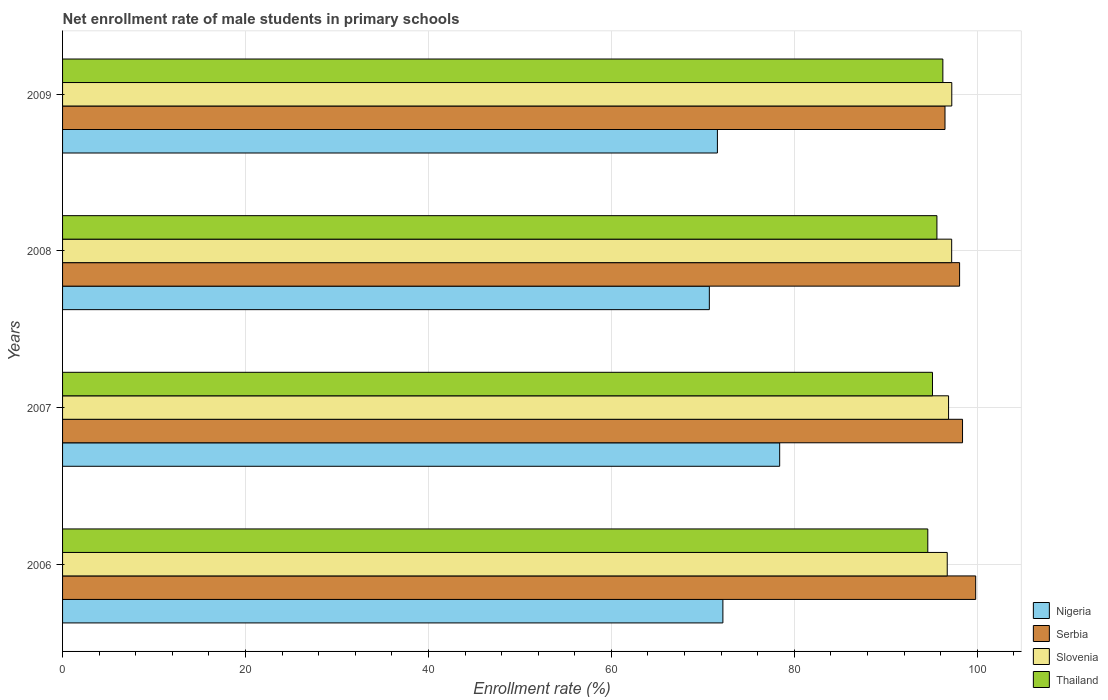How many groups of bars are there?
Offer a terse response. 4. How many bars are there on the 4th tick from the bottom?
Keep it short and to the point. 4. What is the net enrollment rate of male students in primary schools in Thailand in 2006?
Provide a succinct answer. 94.6. Across all years, what is the maximum net enrollment rate of male students in primary schools in Nigeria?
Your answer should be very brief. 78.4. Across all years, what is the minimum net enrollment rate of male students in primary schools in Nigeria?
Offer a terse response. 70.72. In which year was the net enrollment rate of male students in primary schools in Slovenia maximum?
Your response must be concise. 2009. In which year was the net enrollment rate of male students in primary schools in Nigeria minimum?
Your response must be concise. 2008. What is the total net enrollment rate of male students in primary schools in Slovenia in the graph?
Make the answer very short. 388.03. What is the difference between the net enrollment rate of male students in primary schools in Serbia in 2006 and that in 2009?
Offer a terse response. 3.36. What is the difference between the net enrollment rate of male students in primary schools in Nigeria in 2006 and the net enrollment rate of male students in primary schools in Slovenia in 2008?
Your answer should be compact. -25.01. What is the average net enrollment rate of male students in primary schools in Serbia per year?
Provide a succinct answer. 98.2. In the year 2008, what is the difference between the net enrollment rate of male students in primary schools in Slovenia and net enrollment rate of male students in primary schools in Nigeria?
Your answer should be very brief. 26.49. What is the ratio of the net enrollment rate of male students in primary schools in Nigeria in 2006 to that in 2009?
Provide a succinct answer. 1.01. Is the net enrollment rate of male students in primary schools in Nigeria in 2008 less than that in 2009?
Provide a short and direct response. Yes. What is the difference between the highest and the second highest net enrollment rate of male students in primary schools in Thailand?
Offer a terse response. 0.65. What is the difference between the highest and the lowest net enrollment rate of male students in primary schools in Slovenia?
Provide a succinct answer. 0.5. In how many years, is the net enrollment rate of male students in primary schools in Slovenia greater than the average net enrollment rate of male students in primary schools in Slovenia taken over all years?
Your answer should be compact. 2. Is the sum of the net enrollment rate of male students in primary schools in Serbia in 2007 and 2008 greater than the maximum net enrollment rate of male students in primary schools in Nigeria across all years?
Provide a succinct answer. Yes. Is it the case that in every year, the sum of the net enrollment rate of male students in primary schools in Serbia and net enrollment rate of male students in primary schools in Nigeria is greater than the sum of net enrollment rate of male students in primary schools in Slovenia and net enrollment rate of male students in primary schools in Thailand?
Your response must be concise. Yes. What does the 4th bar from the top in 2006 represents?
Ensure brevity in your answer.  Nigeria. What does the 2nd bar from the bottom in 2009 represents?
Your answer should be very brief. Serbia. Are all the bars in the graph horizontal?
Offer a terse response. Yes. How many years are there in the graph?
Your answer should be very brief. 4. Are the values on the major ticks of X-axis written in scientific E-notation?
Keep it short and to the point. No. Does the graph contain any zero values?
Offer a terse response. No. Does the graph contain grids?
Ensure brevity in your answer.  Yes. How many legend labels are there?
Your answer should be very brief. 4. How are the legend labels stacked?
Offer a terse response. Vertical. What is the title of the graph?
Ensure brevity in your answer.  Net enrollment rate of male students in primary schools. What is the label or title of the X-axis?
Offer a very short reply. Enrollment rate (%). What is the label or title of the Y-axis?
Offer a very short reply. Years. What is the Enrollment rate (%) of Nigeria in 2006?
Offer a terse response. 72.2. What is the Enrollment rate (%) of Serbia in 2006?
Your response must be concise. 99.84. What is the Enrollment rate (%) of Slovenia in 2006?
Provide a succinct answer. 96.72. What is the Enrollment rate (%) of Thailand in 2006?
Provide a short and direct response. 94.6. What is the Enrollment rate (%) in Nigeria in 2007?
Offer a very short reply. 78.4. What is the Enrollment rate (%) of Serbia in 2007?
Provide a short and direct response. 98.4. What is the Enrollment rate (%) in Slovenia in 2007?
Your answer should be very brief. 96.87. What is the Enrollment rate (%) of Thailand in 2007?
Ensure brevity in your answer.  95.11. What is the Enrollment rate (%) in Nigeria in 2008?
Keep it short and to the point. 70.72. What is the Enrollment rate (%) of Serbia in 2008?
Provide a succinct answer. 98.08. What is the Enrollment rate (%) in Slovenia in 2008?
Make the answer very short. 97.21. What is the Enrollment rate (%) of Thailand in 2008?
Your response must be concise. 95.6. What is the Enrollment rate (%) in Nigeria in 2009?
Provide a short and direct response. 71.6. What is the Enrollment rate (%) of Serbia in 2009?
Offer a very short reply. 96.48. What is the Enrollment rate (%) of Slovenia in 2009?
Make the answer very short. 97.22. What is the Enrollment rate (%) of Thailand in 2009?
Keep it short and to the point. 96.25. Across all years, what is the maximum Enrollment rate (%) of Nigeria?
Ensure brevity in your answer.  78.4. Across all years, what is the maximum Enrollment rate (%) in Serbia?
Ensure brevity in your answer.  99.84. Across all years, what is the maximum Enrollment rate (%) in Slovenia?
Your answer should be compact. 97.22. Across all years, what is the maximum Enrollment rate (%) of Thailand?
Provide a succinct answer. 96.25. Across all years, what is the minimum Enrollment rate (%) of Nigeria?
Offer a very short reply. 70.72. Across all years, what is the minimum Enrollment rate (%) of Serbia?
Ensure brevity in your answer.  96.48. Across all years, what is the minimum Enrollment rate (%) of Slovenia?
Your answer should be very brief. 96.72. Across all years, what is the minimum Enrollment rate (%) in Thailand?
Your answer should be compact. 94.6. What is the total Enrollment rate (%) in Nigeria in the graph?
Make the answer very short. 292.91. What is the total Enrollment rate (%) in Serbia in the graph?
Offer a very short reply. 392.79. What is the total Enrollment rate (%) of Slovenia in the graph?
Your answer should be compact. 388.03. What is the total Enrollment rate (%) in Thailand in the graph?
Make the answer very short. 381.56. What is the difference between the Enrollment rate (%) of Nigeria in 2006 and that in 2007?
Provide a short and direct response. -6.21. What is the difference between the Enrollment rate (%) in Serbia in 2006 and that in 2007?
Ensure brevity in your answer.  1.44. What is the difference between the Enrollment rate (%) in Slovenia in 2006 and that in 2007?
Provide a short and direct response. -0.15. What is the difference between the Enrollment rate (%) of Thailand in 2006 and that in 2007?
Keep it short and to the point. -0.51. What is the difference between the Enrollment rate (%) in Nigeria in 2006 and that in 2008?
Keep it short and to the point. 1.48. What is the difference between the Enrollment rate (%) of Serbia in 2006 and that in 2008?
Provide a short and direct response. 1.76. What is the difference between the Enrollment rate (%) of Slovenia in 2006 and that in 2008?
Your response must be concise. -0.49. What is the difference between the Enrollment rate (%) in Thailand in 2006 and that in 2008?
Provide a succinct answer. -1. What is the difference between the Enrollment rate (%) of Nigeria in 2006 and that in 2009?
Give a very brief answer. 0.6. What is the difference between the Enrollment rate (%) in Serbia in 2006 and that in 2009?
Offer a terse response. 3.36. What is the difference between the Enrollment rate (%) of Slovenia in 2006 and that in 2009?
Keep it short and to the point. -0.5. What is the difference between the Enrollment rate (%) in Thailand in 2006 and that in 2009?
Provide a short and direct response. -1.65. What is the difference between the Enrollment rate (%) in Nigeria in 2007 and that in 2008?
Offer a terse response. 7.69. What is the difference between the Enrollment rate (%) in Serbia in 2007 and that in 2008?
Your answer should be very brief. 0.32. What is the difference between the Enrollment rate (%) in Slovenia in 2007 and that in 2008?
Your response must be concise. -0.34. What is the difference between the Enrollment rate (%) in Thailand in 2007 and that in 2008?
Your answer should be very brief. -0.49. What is the difference between the Enrollment rate (%) of Nigeria in 2007 and that in 2009?
Ensure brevity in your answer.  6.81. What is the difference between the Enrollment rate (%) in Serbia in 2007 and that in 2009?
Ensure brevity in your answer.  1.92. What is the difference between the Enrollment rate (%) in Slovenia in 2007 and that in 2009?
Provide a short and direct response. -0.35. What is the difference between the Enrollment rate (%) of Thailand in 2007 and that in 2009?
Ensure brevity in your answer.  -1.13. What is the difference between the Enrollment rate (%) of Nigeria in 2008 and that in 2009?
Provide a short and direct response. -0.88. What is the difference between the Enrollment rate (%) of Serbia in 2008 and that in 2009?
Provide a short and direct response. 1.6. What is the difference between the Enrollment rate (%) in Slovenia in 2008 and that in 2009?
Your answer should be very brief. -0.01. What is the difference between the Enrollment rate (%) in Thailand in 2008 and that in 2009?
Your answer should be compact. -0.65. What is the difference between the Enrollment rate (%) in Nigeria in 2006 and the Enrollment rate (%) in Serbia in 2007?
Offer a terse response. -26.2. What is the difference between the Enrollment rate (%) in Nigeria in 2006 and the Enrollment rate (%) in Slovenia in 2007?
Provide a succinct answer. -24.67. What is the difference between the Enrollment rate (%) in Nigeria in 2006 and the Enrollment rate (%) in Thailand in 2007?
Give a very brief answer. -22.92. What is the difference between the Enrollment rate (%) in Serbia in 2006 and the Enrollment rate (%) in Slovenia in 2007?
Keep it short and to the point. 2.97. What is the difference between the Enrollment rate (%) in Serbia in 2006 and the Enrollment rate (%) in Thailand in 2007?
Ensure brevity in your answer.  4.72. What is the difference between the Enrollment rate (%) in Slovenia in 2006 and the Enrollment rate (%) in Thailand in 2007?
Offer a very short reply. 1.61. What is the difference between the Enrollment rate (%) of Nigeria in 2006 and the Enrollment rate (%) of Serbia in 2008?
Your response must be concise. -25.88. What is the difference between the Enrollment rate (%) of Nigeria in 2006 and the Enrollment rate (%) of Slovenia in 2008?
Provide a succinct answer. -25.01. What is the difference between the Enrollment rate (%) of Nigeria in 2006 and the Enrollment rate (%) of Thailand in 2008?
Offer a very short reply. -23.4. What is the difference between the Enrollment rate (%) of Serbia in 2006 and the Enrollment rate (%) of Slovenia in 2008?
Give a very brief answer. 2.63. What is the difference between the Enrollment rate (%) in Serbia in 2006 and the Enrollment rate (%) in Thailand in 2008?
Keep it short and to the point. 4.24. What is the difference between the Enrollment rate (%) of Slovenia in 2006 and the Enrollment rate (%) of Thailand in 2008?
Ensure brevity in your answer.  1.13. What is the difference between the Enrollment rate (%) in Nigeria in 2006 and the Enrollment rate (%) in Serbia in 2009?
Provide a short and direct response. -24.29. What is the difference between the Enrollment rate (%) in Nigeria in 2006 and the Enrollment rate (%) in Slovenia in 2009?
Offer a terse response. -25.03. What is the difference between the Enrollment rate (%) in Nigeria in 2006 and the Enrollment rate (%) in Thailand in 2009?
Ensure brevity in your answer.  -24.05. What is the difference between the Enrollment rate (%) of Serbia in 2006 and the Enrollment rate (%) of Slovenia in 2009?
Give a very brief answer. 2.61. What is the difference between the Enrollment rate (%) of Serbia in 2006 and the Enrollment rate (%) of Thailand in 2009?
Make the answer very short. 3.59. What is the difference between the Enrollment rate (%) of Slovenia in 2006 and the Enrollment rate (%) of Thailand in 2009?
Give a very brief answer. 0.48. What is the difference between the Enrollment rate (%) of Nigeria in 2007 and the Enrollment rate (%) of Serbia in 2008?
Give a very brief answer. -19.67. What is the difference between the Enrollment rate (%) of Nigeria in 2007 and the Enrollment rate (%) of Slovenia in 2008?
Offer a terse response. -18.81. What is the difference between the Enrollment rate (%) of Nigeria in 2007 and the Enrollment rate (%) of Thailand in 2008?
Give a very brief answer. -17.19. What is the difference between the Enrollment rate (%) in Serbia in 2007 and the Enrollment rate (%) in Slovenia in 2008?
Keep it short and to the point. 1.19. What is the difference between the Enrollment rate (%) of Serbia in 2007 and the Enrollment rate (%) of Thailand in 2008?
Offer a very short reply. 2.8. What is the difference between the Enrollment rate (%) in Slovenia in 2007 and the Enrollment rate (%) in Thailand in 2008?
Provide a succinct answer. 1.27. What is the difference between the Enrollment rate (%) in Nigeria in 2007 and the Enrollment rate (%) in Serbia in 2009?
Give a very brief answer. -18.08. What is the difference between the Enrollment rate (%) in Nigeria in 2007 and the Enrollment rate (%) in Slovenia in 2009?
Ensure brevity in your answer.  -18.82. What is the difference between the Enrollment rate (%) in Nigeria in 2007 and the Enrollment rate (%) in Thailand in 2009?
Your response must be concise. -17.84. What is the difference between the Enrollment rate (%) of Serbia in 2007 and the Enrollment rate (%) of Slovenia in 2009?
Offer a very short reply. 1.17. What is the difference between the Enrollment rate (%) in Serbia in 2007 and the Enrollment rate (%) in Thailand in 2009?
Make the answer very short. 2.15. What is the difference between the Enrollment rate (%) in Slovenia in 2007 and the Enrollment rate (%) in Thailand in 2009?
Provide a succinct answer. 0.62. What is the difference between the Enrollment rate (%) of Nigeria in 2008 and the Enrollment rate (%) of Serbia in 2009?
Your answer should be very brief. -25.77. What is the difference between the Enrollment rate (%) in Nigeria in 2008 and the Enrollment rate (%) in Slovenia in 2009?
Make the answer very short. -26.51. What is the difference between the Enrollment rate (%) of Nigeria in 2008 and the Enrollment rate (%) of Thailand in 2009?
Offer a very short reply. -25.53. What is the difference between the Enrollment rate (%) of Serbia in 2008 and the Enrollment rate (%) of Slovenia in 2009?
Provide a succinct answer. 0.85. What is the difference between the Enrollment rate (%) of Serbia in 2008 and the Enrollment rate (%) of Thailand in 2009?
Provide a short and direct response. 1.83. What is the difference between the Enrollment rate (%) in Slovenia in 2008 and the Enrollment rate (%) in Thailand in 2009?
Your answer should be compact. 0.96. What is the average Enrollment rate (%) in Nigeria per year?
Your answer should be compact. 73.23. What is the average Enrollment rate (%) of Serbia per year?
Your answer should be very brief. 98.2. What is the average Enrollment rate (%) of Slovenia per year?
Provide a short and direct response. 97.01. What is the average Enrollment rate (%) in Thailand per year?
Keep it short and to the point. 95.39. In the year 2006, what is the difference between the Enrollment rate (%) in Nigeria and Enrollment rate (%) in Serbia?
Provide a short and direct response. -27.64. In the year 2006, what is the difference between the Enrollment rate (%) in Nigeria and Enrollment rate (%) in Slovenia?
Offer a very short reply. -24.53. In the year 2006, what is the difference between the Enrollment rate (%) of Nigeria and Enrollment rate (%) of Thailand?
Keep it short and to the point. -22.4. In the year 2006, what is the difference between the Enrollment rate (%) of Serbia and Enrollment rate (%) of Slovenia?
Your answer should be compact. 3.11. In the year 2006, what is the difference between the Enrollment rate (%) of Serbia and Enrollment rate (%) of Thailand?
Ensure brevity in your answer.  5.24. In the year 2006, what is the difference between the Enrollment rate (%) in Slovenia and Enrollment rate (%) in Thailand?
Ensure brevity in your answer.  2.12. In the year 2007, what is the difference between the Enrollment rate (%) in Nigeria and Enrollment rate (%) in Serbia?
Offer a terse response. -19.99. In the year 2007, what is the difference between the Enrollment rate (%) of Nigeria and Enrollment rate (%) of Slovenia?
Ensure brevity in your answer.  -18.47. In the year 2007, what is the difference between the Enrollment rate (%) of Nigeria and Enrollment rate (%) of Thailand?
Provide a succinct answer. -16.71. In the year 2007, what is the difference between the Enrollment rate (%) in Serbia and Enrollment rate (%) in Slovenia?
Give a very brief answer. 1.53. In the year 2007, what is the difference between the Enrollment rate (%) of Serbia and Enrollment rate (%) of Thailand?
Give a very brief answer. 3.29. In the year 2007, what is the difference between the Enrollment rate (%) of Slovenia and Enrollment rate (%) of Thailand?
Your response must be concise. 1.76. In the year 2008, what is the difference between the Enrollment rate (%) in Nigeria and Enrollment rate (%) in Serbia?
Your answer should be very brief. -27.36. In the year 2008, what is the difference between the Enrollment rate (%) in Nigeria and Enrollment rate (%) in Slovenia?
Provide a succinct answer. -26.5. In the year 2008, what is the difference between the Enrollment rate (%) in Nigeria and Enrollment rate (%) in Thailand?
Provide a short and direct response. -24.88. In the year 2008, what is the difference between the Enrollment rate (%) in Serbia and Enrollment rate (%) in Slovenia?
Your response must be concise. 0.87. In the year 2008, what is the difference between the Enrollment rate (%) in Serbia and Enrollment rate (%) in Thailand?
Your answer should be compact. 2.48. In the year 2008, what is the difference between the Enrollment rate (%) of Slovenia and Enrollment rate (%) of Thailand?
Your answer should be very brief. 1.61. In the year 2009, what is the difference between the Enrollment rate (%) of Nigeria and Enrollment rate (%) of Serbia?
Your answer should be compact. -24.88. In the year 2009, what is the difference between the Enrollment rate (%) of Nigeria and Enrollment rate (%) of Slovenia?
Provide a short and direct response. -25.63. In the year 2009, what is the difference between the Enrollment rate (%) of Nigeria and Enrollment rate (%) of Thailand?
Offer a terse response. -24.65. In the year 2009, what is the difference between the Enrollment rate (%) in Serbia and Enrollment rate (%) in Slovenia?
Give a very brief answer. -0.74. In the year 2009, what is the difference between the Enrollment rate (%) of Serbia and Enrollment rate (%) of Thailand?
Your answer should be very brief. 0.23. In the year 2009, what is the difference between the Enrollment rate (%) in Slovenia and Enrollment rate (%) in Thailand?
Provide a short and direct response. 0.98. What is the ratio of the Enrollment rate (%) in Nigeria in 2006 to that in 2007?
Ensure brevity in your answer.  0.92. What is the ratio of the Enrollment rate (%) of Serbia in 2006 to that in 2007?
Offer a very short reply. 1.01. What is the ratio of the Enrollment rate (%) of Thailand in 2006 to that in 2007?
Provide a short and direct response. 0.99. What is the ratio of the Enrollment rate (%) in Nigeria in 2006 to that in 2008?
Provide a short and direct response. 1.02. What is the ratio of the Enrollment rate (%) in Serbia in 2006 to that in 2008?
Make the answer very short. 1.02. What is the ratio of the Enrollment rate (%) of Nigeria in 2006 to that in 2009?
Offer a terse response. 1.01. What is the ratio of the Enrollment rate (%) in Serbia in 2006 to that in 2009?
Offer a very short reply. 1.03. What is the ratio of the Enrollment rate (%) of Slovenia in 2006 to that in 2009?
Your answer should be very brief. 0.99. What is the ratio of the Enrollment rate (%) of Thailand in 2006 to that in 2009?
Your answer should be very brief. 0.98. What is the ratio of the Enrollment rate (%) of Nigeria in 2007 to that in 2008?
Make the answer very short. 1.11. What is the ratio of the Enrollment rate (%) of Serbia in 2007 to that in 2008?
Make the answer very short. 1. What is the ratio of the Enrollment rate (%) of Slovenia in 2007 to that in 2008?
Provide a short and direct response. 1. What is the ratio of the Enrollment rate (%) in Nigeria in 2007 to that in 2009?
Offer a terse response. 1.1. What is the ratio of the Enrollment rate (%) of Serbia in 2007 to that in 2009?
Provide a short and direct response. 1.02. What is the ratio of the Enrollment rate (%) in Slovenia in 2007 to that in 2009?
Make the answer very short. 1. What is the ratio of the Enrollment rate (%) of Thailand in 2007 to that in 2009?
Make the answer very short. 0.99. What is the ratio of the Enrollment rate (%) of Nigeria in 2008 to that in 2009?
Ensure brevity in your answer.  0.99. What is the ratio of the Enrollment rate (%) in Serbia in 2008 to that in 2009?
Provide a succinct answer. 1.02. What is the difference between the highest and the second highest Enrollment rate (%) of Nigeria?
Give a very brief answer. 6.21. What is the difference between the highest and the second highest Enrollment rate (%) of Serbia?
Provide a succinct answer. 1.44. What is the difference between the highest and the second highest Enrollment rate (%) of Slovenia?
Offer a terse response. 0.01. What is the difference between the highest and the second highest Enrollment rate (%) of Thailand?
Your response must be concise. 0.65. What is the difference between the highest and the lowest Enrollment rate (%) of Nigeria?
Your answer should be compact. 7.69. What is the difference between the highest and the lowest Enrollment rate (%) in Serbia?
Ensure brevity in your answer.  3.36. What is the difference between the highest and the lowest Enrollment rate (%) in Slovenia?
Ensure brevity in your answer.  0.5. What is the difference between the highest and the lowest Enrollment rate (%) of Thailand?
Give a very brief answer. 1.65. 